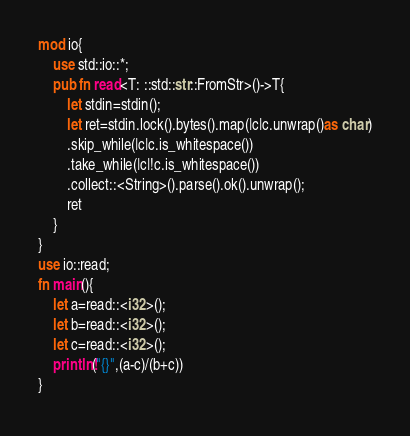Convert code to text. <code><loc_0><loc_0><loc_500><loc_500><_Rust_>mod io{
    use std::io::*;
    pub fn read<T: ::std::str::FromStr>()->T{
        let stdin=stdin();
        let ret=stdin.lock().bytes().map(|c|c.unwrap()as char)
        .skip_while(|c|c.is_whitespace())
        .take_while(|c|!c.is_whitespace())
        .collect::<String>().parse().ok().unwrap();
        ret
    }
}
use io::read;
fn main(){
    let a=read::<i32>();
    let b=read::<i32>();
    let c=read::<i32>();
    println!("{}",(a-c)/(b+c))
}
</code> 